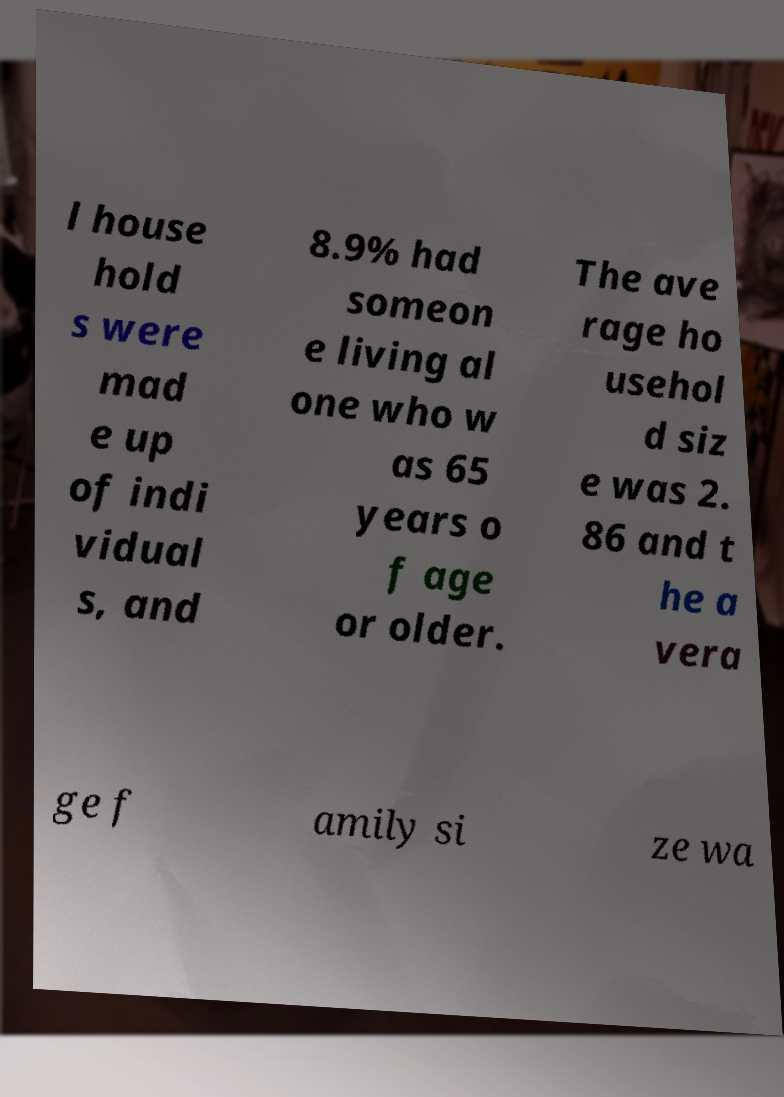I need the written content from this picture converted into text. Can you do that? l house hold s were mad e up of indi vidual s, and 8.9% had someon e living al one who w as 65 years o f age or older. The ave rage ho usehol d siz e was 2. 86 and t he a vera ge f amily si ze wa 